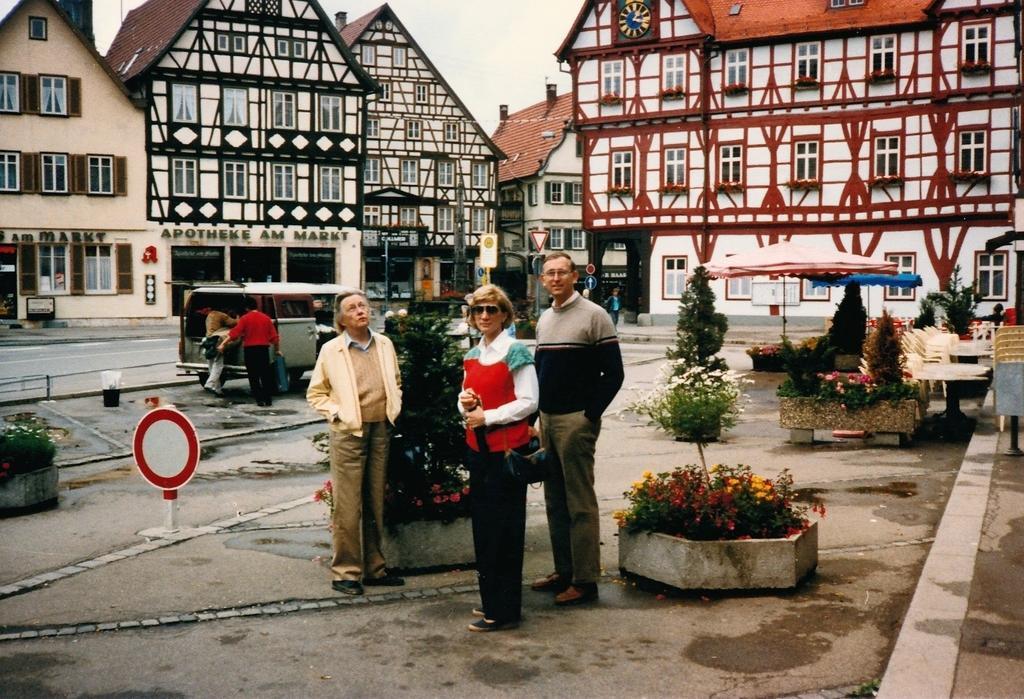In one or two sentences, can you explain what this image depicts? In this picture we can see described about two old men and a women standing and giving a pose into the camera. Behind we can see silver color van and 3D design roof houses. 